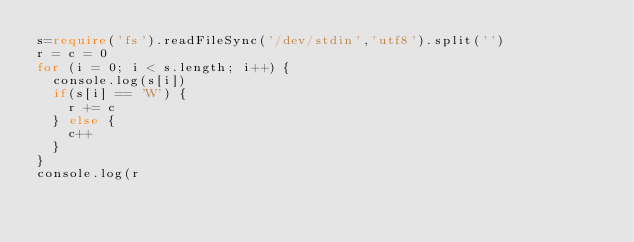Convert code to text. <code><loc_0><loc_0><loc_500><loc_500><_TypeScript_>s=require('fs').readFileSync('/dev/stdin','utf8').split('')
r = c = 0
for (i = 0; i < s.length; i++) {
	console.log(s[i])
	if(s[i] == 'W') {
		r += c
	} else {
		c++
	}
}
console.log(r</code> 